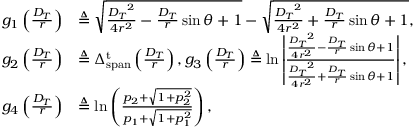Convert formula to latex. <formula><loc_0><loc_0><loc_500><loc_500>\begin{array} { r l } { { g _ { 1 } } \left ( { \frac { { { D _ { T } } } } { r } } \right ) } & { \triangle q \sqrt { \frac { { { D _ { T } } ^ { 2 } } } { { 4 { r ^ { 2 } } } } - \frac { { { D _ { T } } } } { r } \sin \theta + 1 } - \sqrt { \frac { { { D _ { T } } ^ { 2 } } } { { 4 { r ^ { 2 } } } } + \frac { { { D _ { T } } } } { r } \sin \theta + 1 } , } \\ { { g _ { 2 } } \left ( { \frac { { { D _ { T } } } } { r } } \right ) } & { \triangle q \Delta _ { s p a n } ^ { t } \left ( \frac { { { D _ { T } } } } { r } \right ) , { g _ { 3 } } \left ( { \frac { { { D _ { T } } } } { r } } \right ) \triangle q \ln \left | { \frac { { \frac { { { D _ { T } } ^ { 2 } } } { { 4 { r ^ { 2 } } } } - \frac { { { D _ { T } } } } { r } \sin \theta + 1 } } { { \frac { { { D _ { T } } ^ { 2 } } } { { 4 { r ^ { 2 } } } } + \frac { { { D _ { T } } } } { r } \sin \theta + 1 } } } \right | , } \\ { { g _ { 4 } } \left ( { \frac { { { D _ { T } } } } { r } } \right ) } & { \triangle q \ln \left ( \frac { { { p _ { 2 } } + \sqrt { 1 + p _ { 2 } ^ { 2 } } } } { { { p _ { 1 } } + \sqrt { 1 + p _ { 1 } ^ { 2 } } } } \right ) , } \end{array}</formula> 